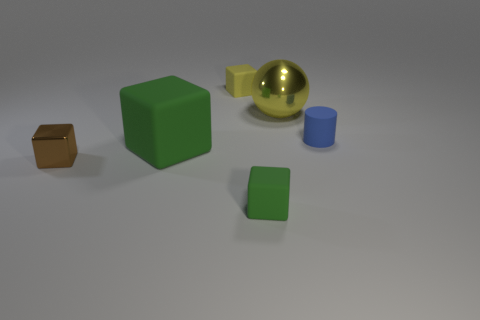Subtract all big cubes. How many cubes are left? 3 Subtract all brown cubes. How many cubes are left? 3 Subtract all blocks. How many objects are left? 2 Add 1 small shiny cylinders. How many objects exist? 7 Subtract 1 balls. How many balls are left? 0 Subtract all brown cylinders. Subtract all purple spheres. How many cylinders are left? 1 Subtract all gray spheres. How many brown cubes are left? 1 Subtract all big shiny objects. Subtract all yellow things. How many objects are left? 3 Add 3 large yellow things. How many large yellow things are left? 4 Add 1 tiny blue things. How many tiny blue things exist? 2 